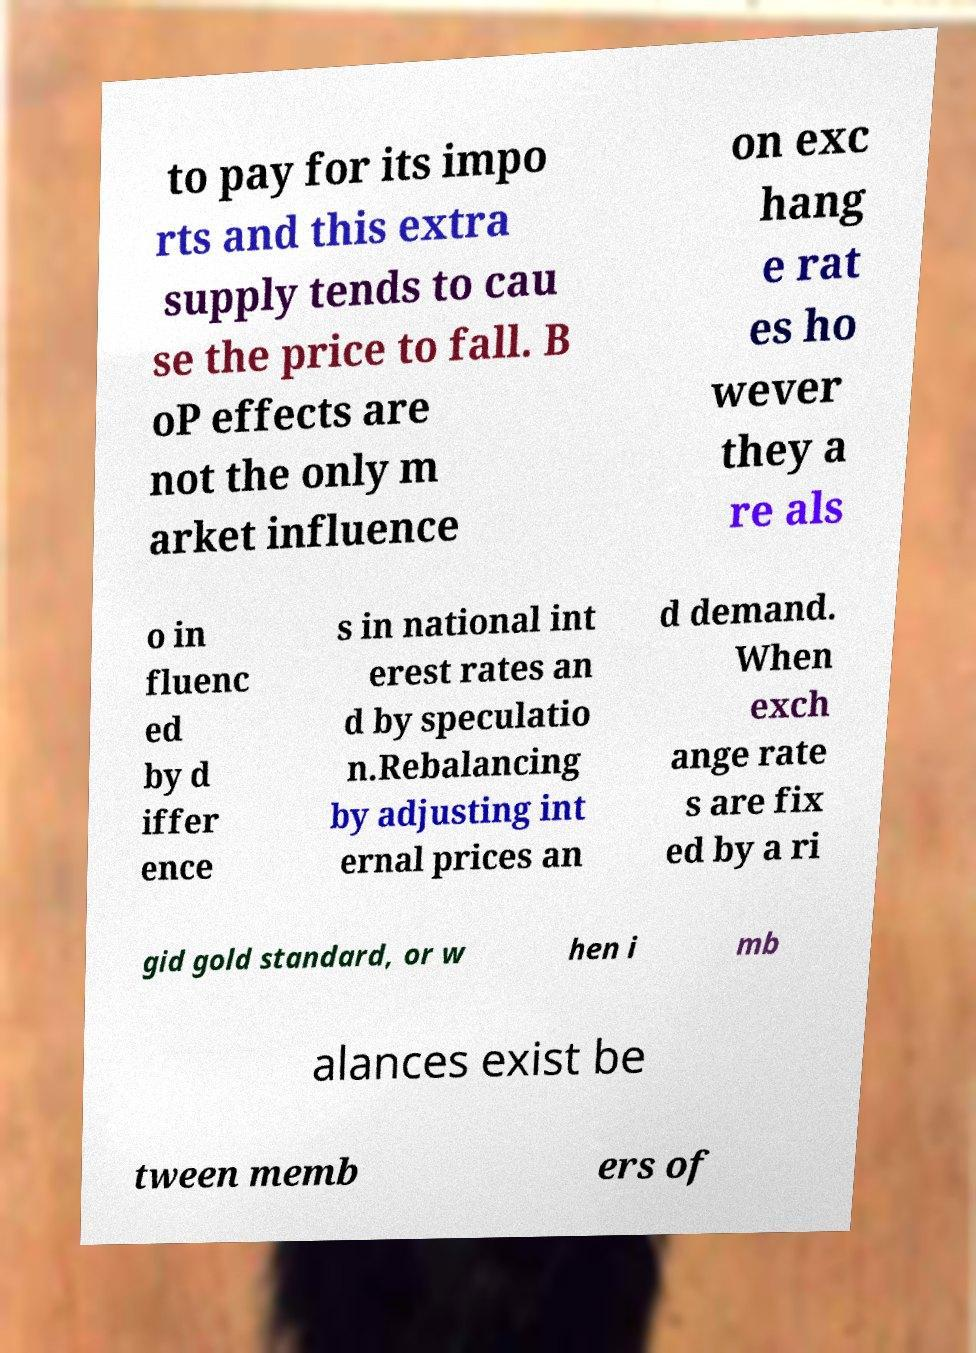Please read and relay the text visible in this image. What does it say? to pay for its impo rts and this extra supply tends to cau se the price to fall. B oP effects are not the only m arket influence on exc hang e rat es ho wever they a re als o in fluenc ed by d iffer ence s in national int erest rates an d by speculatio n.Rebalancing by adjusting int ernal prices an d demand. When exch ange rate s are fix ed by a ri gid gold standard, or w hen i mb alances exist be tween memb ers of 